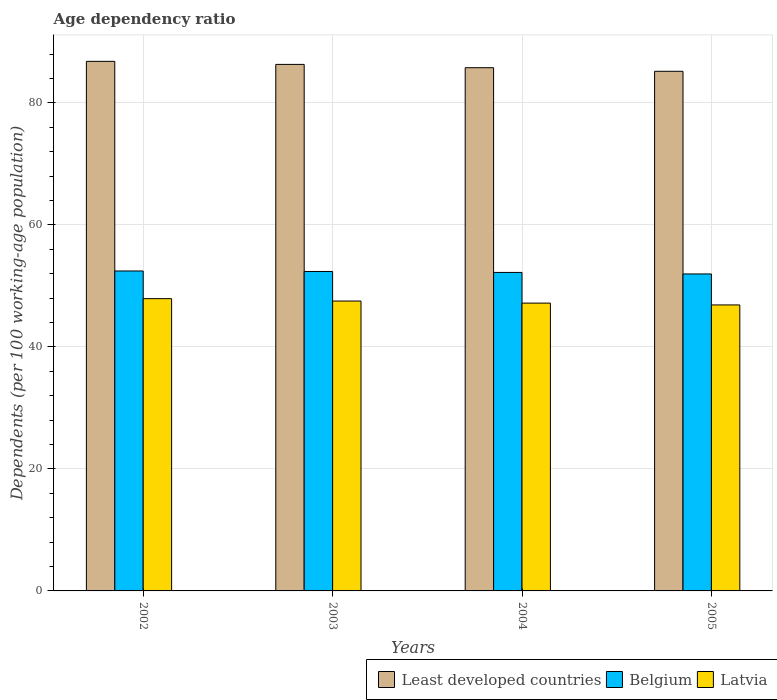How many different coloured bars are there?
Give a very brief answer. 3. How many groups of bars are there?
Provide a short and direct response. 4. Are the number of bars on each tick of the X-axis equal?
Provide a succinct answer. Yes. How many bars are there on the 2nd tick from the left?
Your response must be concise. 3. In how many cases, is the number of bars for a given year not equal to the number of legend labels?
Make the answer very short. 0. What is the age dependency ratio in in Belgium in 2002?
Give a very brief answer. 52.46. Across all years, what is the maximum age dependency ratio in in Least developed countries?
Give a very brief answer. 86.83. Across all years, what is the minimum age dependency ratio in in Latvia?
Make the answer very short. 46.89. What is the total age dependency ratio in in Latvia in the graph?
Offer a very short reply. 189.53. What is the difference between the age dependency ratio in in Least developed countries in 2002 and that in 2005?
Make the answer very short. 1.63. What is the difference between the age dependency ratio in in Latvia in 2005 and the age dependency ratio in in Belgium in 2002?
Keep it short and to the point. -5.57. What is the average age dependency ratio in in Least developed countries per year?
Your answer should be very brief. 86.03. In the year 2005, what is the difference between the age dependency ratio in in Belgium and age dependency ratio in in Least developed countries?
Ensure brevity in your answer.  -33.23. What is the ratio of the age dependency ratio in in Latvia in 2004 to that in 2005?
Offer a very short reply. 1.01. What is the difference between the highest and the second highest age dependency ratio in in Least developed countries?
Keep it short and to the point. 0.5. What is the difference between the highest and the lowest age dependency ratio in in Least developed countries?
Provide a succinct answer. 1.63. In how many years, is the age dependency ratio in in Latvia greater than the average age dependency ratio in in Latvia taken over all years?
Your answer should be very brief. 2. Is the sum of the age dependency ratio in in Latvia in 2002 and 2004 greater than the maximum age dependency ratio in in Belgium across all years?
Offer a terse response. Yes. What does the 3rd bar from the right in 2003 represents?
Ensure brevity in your answer.  Least developed countries. Is it the case that in every year, the sum of the age dependency ratio in in Least developed countries and age dependency ratio in in Latvia is greater than the age dependency ratio in in Belgium?
Provide a succinct answer. Yes. How many years are there in the graph?
Your response must be concise. 4. What is the difference between two consecutive major ticks on the Y-axis?
Your response must be concise. 20. Where does the legend appear in the graph?
Ensure brevity in your answer.  Bottom right. How are the legend labels stacked?
Offer a very short reply. Horizontal. What is the title of the graph?
Your answer should be compact. Age dependency ratio. Does "Ghana" appear as one of the legend labels in the graph?
Offer a very short reply. No. What is the label or title of the Y-axis?
Make the answer very short. Dependents (per 100 working-age population). What is the Dependents (per 100 working-age population) in Least developed countries in 2002?
Offer a very short reply. 86.83. What is the Dependents (per 100 working-age population) of Belgium in 2002?
Provide a succinct answer. 52.46. What is the Dependents (per 100 working-age population) in Latvia in 2002?
Offer a very short reply. 47.92. What is the Dependents (per 100 working-age population) of Least developed countries in 2003?
Your answer should be very brief. 86.33. What is the Dependents (per 100 working-age population) of Belgium in 2003?
Ensure brevity in your answer.  52.37. What is the Dependents (per 100 working-age population) of Latvia in 2003?
Your response must be concise. 47.53. What is the Dependents (per 100 working-age population) of Least developed countries in 2004?
Make the answer very short. 85.78. What is the Dependents (per 100 working-age population) in Belgium in 2004?
Ensure brevity in your answer.  52.22. What is the Dependents (per 100 working-age population) of Latvia in 2004?
Offer a very short reply. 47.19. What is the Dependents (per 100 working-age population) of Least developed countries in 2005?
Provide a succinct answer. 85.2. What is the Dependents (per 100 working-age population) in Belgium in 2005?
Make the answer very short. 51.97. What is the Dependents (per 100 working-age population) in Latvia in 2005?
Your response must be concise. 46.89. Across all years, what is the maximum Dependents (per 100 working-age population) in Least developed countries?
Offer a terse response. 86.83. Across all years, what is the maximum Dependents (per 100 working-age population) in Belgium?
Ensure brevity in your answer.  52.46. Across all years, what is the maximum Dependents (per 100 working-age population) of Latvia?
Your answer should be very brief. 47.92. Across all years, what is the minimum Dependents (per 100 working-age population) of Least developed countries?
Offer a very short reply. 85.2. Across all years, what is the minimum Dependents (per 100 working-age population) of Belgium?
Offer a very short reply. 51.97. Across all years, what is the minimum Dependents (per 100 working-age population) of Latvia?
Make the answer very short. 46.89. What is the total Dependents (per 100 working-age population) of Least developed countries in the graph?
Your answer should be very brief. 344.13. What is the total Dependents (per 100 working-age population) in Belgium in the graph?
Provide a short and direct response. 209.02. What is the total Dependents (per 100 working-age population) in Latvia in the graph?
Offer a very short reply. 189.53. What is the difference between the Dependents (per 100 working-age population) of Least developed countries in 2002 and that in 2003?
Provide a short and direct response. 0.5. What is the difference between the Dependents (per 100 working-age population) of Belgium in 2002 and that in 2003?
Provide a succinct answer. 0.08. What is the difference between the Dependents (per 100 working-age population) in Latvia in 2002 and that in 2003?
Provide a succinct answer. 0.39. What is the difference between the Dependents (per 100 working-age population) of Least developed countries in 2002 and that in 2004?
Provide a short and direct response. 1.04. What is the difference between the Dependents (per 100 working-age population) in Belgium in 2002 and that in 2004?
Your answer should be compact. 0.24. What is the difference between the Dependents (per 100 working-age population) in Latvia in 2002 and that in 2004?
Your response must be concise. 0.73. What is the difference between the Dependents (per 100 working-age population) of Least developed countries in 2002 and that in 2005?
Keep it short and to the point. 1.63. What is the difference between the Dependents (per 100 working-age population) in Belgium in 2002 and that in 2005?
Make the answer very short. 0.49. What is the difference between the Dependents (per 100 working-age population) of Latvia in 2002 and that in 2005?
Your answer should be compact. 1.03. What is the difference between the Dependents (per 100 working-age population) in Least developed countries in 2003 and that in 2004?
Offer a terse response. 0.54. What is the difference between the Dependents (per 100 working-age population) in Belgium in 2003 and that in 2004?
Provide a succinct answer. 0.15. What is the difference between the Dependents (per 100 working-age population) in Latvia in 2003 and that in 2004?
Ensure brevity in your answer.  0.34. What is the difference between the Dependents (per 100 working-age population) of Least developed countries in 2003 and that in 2005?
Your answer should be compact. 1.13. What is the difference between the Dependents (per 100 working-age population) in Belgium in 2003 and that in 2005?
Give a very brief answer. 0.4. What is the difference between the Dependents (per 100 working-age population) of Latvia in 2003 and that in 2005?
Make the answer very short. 0.64. What is the difference between the Dependents (per 100 working-age population) of Least developed countries in 2004 and that in 2005?
Keep it short and to the point. 0.59. What is the difference between the Dependents (per 100 working-age population) of Belgium in 2004 and that in 2005?
Your response must be concise. 0.25. What is the difference between the Dependents (per 100 working-age population) in Latvia in 2004 and that in 2005?
Offer a very short reply. 0.3. What is the difference between the Dependents (per 100 working-age population) in Least developed countries in 2002 and the Dependents (per 100 working-age population) in Belgium in 2003?
Offer a very short reply. 34.45. What is the difference between the Dependents (per 100 working-age population) of Least developed countries in 2002 and the Dependents (per 100 working-age population) of Latvia in 2003?
Your answer should be compact. 39.3. What is the difference between the Dependents (per 100 working-age population) of Belgium in 2002 and the Dependents (per 100 working-age population) of Latvia in 2003?
Make the answer very short. 4.93. What is the difference between the Dependents (per 100 working-age population) in Least developed countries in 2002 and the Dependents (per 100 working-age population) in Belgium in 2004?
Your answer should be very brief. 34.61. What is the difference between the Dependents (per 100 working-age population) in Least developed countries in 2002 and the Dependents (per 100 working-age population) in Latvia in 2004?
Provide a succinct answer. 39.64. What is the difference between the Dependents (per 100 working-age population) of Belgium in 2002 and the Dependents (per 100 working-age population) of Latvia in 2004?
Make the answer very short. 5.27. What is the difference between the Dependents (per 100 working-age population) in Least developed countries in 2002 and the Dependents (per 100 working-age population) in Belgium in 2005?
Offer a terse response. 34.86. What is the difference between the Dependents (per 100 working-age population) of Least developed countries in 2002 and the Dependents (per 100 working-age population) of Latvia in 2005?
Keep it short and to the point. 39.94. What is the difference between the Dependents (per 100 working-age population) of Belgium in 2002 and the Dependents (per 100 working-age population) of Latvia in 2005?
Your response must be concise. 5.57. What is the difference between the Dependents (per 100 working-age population) of Least developed countries in 2003 and the Dependents (per 100 working-age population) of Belgium in 2004?
Ensure brevity in your answer.  34.11. What is the difference between the Dependents (per 100 working-age population) in Least developed countries in 2003 and the Dependents (per 100 working-age population) in Latvia in 2004?
Provide a short and direct response. 39.14. What is the difference between the Dependents (per 100 working-age population) in Belgium in 2003 and the Dependents (per 100 working-age population) in Latvia in 2004?
Your response must be concise. 5.19. What is the difference between the Dependents (per 100 working-age population) in Least developed countries in 2003 and the Dependents (per 100 working-age population) in Belgium in 2005?
Keep it short and to the point. 34.36. What is the difference between the Dependents (per 100 working-age population) of Least developed countries in 2003 and the Dependents (per 100 working-age population) of Latvia in 2005?
Your answer should be very brief. 39.44. What is the difference between the Dependents (per 100 working-age population) in Belgium in 2003 and the Dependents (per 100 working-age population) in Latvia in 2005?
Make the answer very short. 5.48. What is the difference between the Dependents (per 100 working-age population) of Least developed countries in 2004 and the Dependents (per 100 working-age population) of Belgium in 2005?
Offer a terse response. 33.81. What is the difference between the Dependents (per 100 working-age population) of Least developed countries in 2004 and the Dependents (per 100 working-age population) of Latvia in 2005?
Provide a short and direct response. 38.89. What is the difference between the Dependents (per 100 working-age population) in Belgium in 2004 and the Dependents (per 100 working-age population) in Latvia in 2005?
Your answer should be very brief. 5.33. What is the average Dependents (per 100 working-age population) in Least developed countries per year?
Your response must be concise. 86.03. What is the average Dependents (per 100 working-age population) in Belgium per year?
Provide a succinct answer. 52.26. What is the average Dependents (per 100 working-age population) in Latvia per year?
Offer a very short reply. 47.38. In the year 2002, what is the difference between the Dependents (per 100 working-age population) of Least developed countries and Dependents (per 100 working-age population) of Belgium?
Your answer should be very brief. 34.37. In the year 2002, what is the difference between the Dependents (per 100 working-age population) in Least developed countries and Dependents (per 100 working-age population) in Latvia?
Provide a short and direct response. 38.91. In the year 2002, what is the difference between the Dependents (per 100 working-age population) in Belgium and Dependents (per 100 working-age population) in Latvia?
Provide a short and direct response. 4.54. In the year 2003, what is the difference between the Dependents (per 100 working-age population) in Least developed countries and Dependents (per 100 working-age population) in Belgium?
Keep it short and to the point. 33.95. In the year 2003, what is the difference between the Dependents (per 100 working-age population) in Least developed countries and Dependents (per 100 working-age population) in Latvia?
Make the answer very short. 38.8. In the year 2003, what is the difference between the Dependents (per 100 working-age population) in Belgium and Dependents (per 100 working-age population) in Latvia?
Provide a short and direct response. 4.85. In the year 2004, what is the difference between the Dependents (per 100 working-age population) of Least developed countries and Dependents (per 100 working-age population) of Belgium?
Your answer should be compact. 33.56. In the year 2004, what is the difference between the Dependents (per 100 working-age population) of Least developed countries and Dependents (per 100 working-age population) of Latvia?
Provide a succinct answer. 38.6. In the year 2004, what is the difference between the Dependents (per 100 working-age population) in Belgium and Dependents (per 100 working-age population) in Latvia?
Your answer should be compact. 5.03. In the year 2005, what is the difference between the Dependents (per 100 working-age population) in Least developed countries and Dependents (per 100 working-age population) in Belgium?
Give a very brief answer. 33.23. In the year 2005, what is the difference between the Dependents (per 100 working-age population) of Least developed countries and Dependents (per 100 working-age population) of Latvia?
Your answer should be compact. 38.31. In the year 2005, what is the difference between the Dependents (per 100 working-age population) in Belgium and Dependents (per 100 working-age population) in Latvia?
Provide a short and direct response. 5.08. What is the ratio of the Dependents (per 100 working-age population) of Latvia in 2002 to that in 2003?
Keep it short and to the point. 1.01. What is the ratio of the Dependents (per 100 working-age population) of Least developed countries in 2002 to that in 2004?
Your response must be concise. 1.01. What is the ratio of the Dependents (per 100 working-age population) in Belgium in 2002 to that in 2004?
Your answer should be compact. 1. What is the ratio of the Dependents (per 100 working-age population) in Latvia in 2002 to that in 2004?
Ensure brevity in your answer.  1.02. What is the ratio of the Dependents (per 100 working-age population) of Least developed countries in 2002 to that in 2005?
Your response must be concise. 1.02. What is the ratio of the Dependents (per 100 working-age population) of Belgium in 2002 to that in 2005?
Make the answer very short. 1.01. What is the ratio of the Dependents (per 100 working-age population) of Least developed countries in 2003 to that in 2004?
Offer a terse response. 1.01. What is the ratio of the Dependents (per 100 working-age population) of Latvia in 2003 to that in 2004?
Keep it short and to the point. 1.01. What is the ratio of the Dependents (per 100 working-age population) in Least developed countries in 2003 to that in 2005?
Give a very brief answer. 1.01. What is the ratio of the Dependents (per 100 working-age population) in Latvia in 2003 to that in 2005?
Provide a short and direct response. 1.01. What is the ratio of the Dependents (per 100 working-age population) of Least developed countries in 2004 to that in 2005?
Keep it short and to the point. 1.01. What is the ratio of the Dependents (per 100 working-age population) in Belgium in 2004 to that in 2005?
Make the answer very short. 1. What is the ratio of the Dependents (per 100 working-age population) in Latvia in 2004 to that in 2005?
Keep it short and to the point. 1.01. What is the difference between the highest and the second highest Dependents (per 100 working-age population) in Belgium?
Provide a succinct answer. 0.08. What is the difference between the highest and the second highest Dependents (per 100 working-age population) in Latvia?
Give a very brief answer. 0.39. What is the difference between the highest and the lowest Dependents (per 100 working-age population) in Least developed countries?
Ensure brevity in your answer.  1.63. What is the difference between the highest and the lowest Dependents (per 100 working-age population) in Belgium?
Your answer should be very brief. 0.49. What is the difference between the highest and the lowest Dependents (per 100 working-age population) in Latvia?
Offer a very short reply. 1.03. 